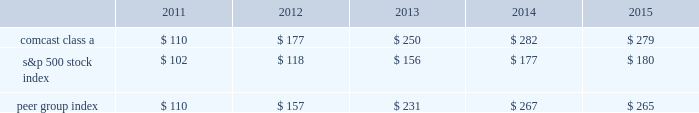Stock performance graph comcast the graph below compares the yearly percentage change in the cumulative total shareholder return on comcast 2019s class a common stock during the five years ended december 31 , 2015 with the cumulative total returns on the standard & poor 2019s 500 stock index and with a select peer group consisting of us and other companies engaged in the cable , communications and media industries .
This peer group consists of us , as well as cablevision systems corporation ( class a ) , dish network corporation ( class a ) , directv inc .
( included through july 24 , 2015 , the date of acquisition by at&t corp. ) and time warner cable inc .
( the 201ccable subgroup 201d ) , and time warner inc. , walt disney company , viacom inc .
( class b ) , twenty-first century fox , inc .
( class a ) , and cbs corporation ( class b ) ( the 201cmedia subgroup 201d ) .
The peer group was constructed as a composite peer group in which the cable subgroup is weighted 63% ( 63 % ) and the media subgroup is weighted 37% ( 37 % ) based on the respective revenue of our cable communications and nbcuniversal segments .
The graph assumes $ 100 was invested on december 31 , 2010 in our class a common stock and in each of the following indices and assumes the reinvestment of dividends .
Comparison of 5 year cumulative total return 12/1412/1312/1212/10 12/15 comcast class a s&p 500 peer group index .
Nbcuniversal nbcuniversal is a wholly owned subsidiary of nbcuniversal holdings and there is no market for its equity securities .
39 comcast 2015 annual report on form 10-k .
What was the ratio of the 5 year cumulative return in 2015 for the performance of comcast class a compared to the s&p 500 stock index? 
Computations: (279 / 180)
Answer: 1.55. 